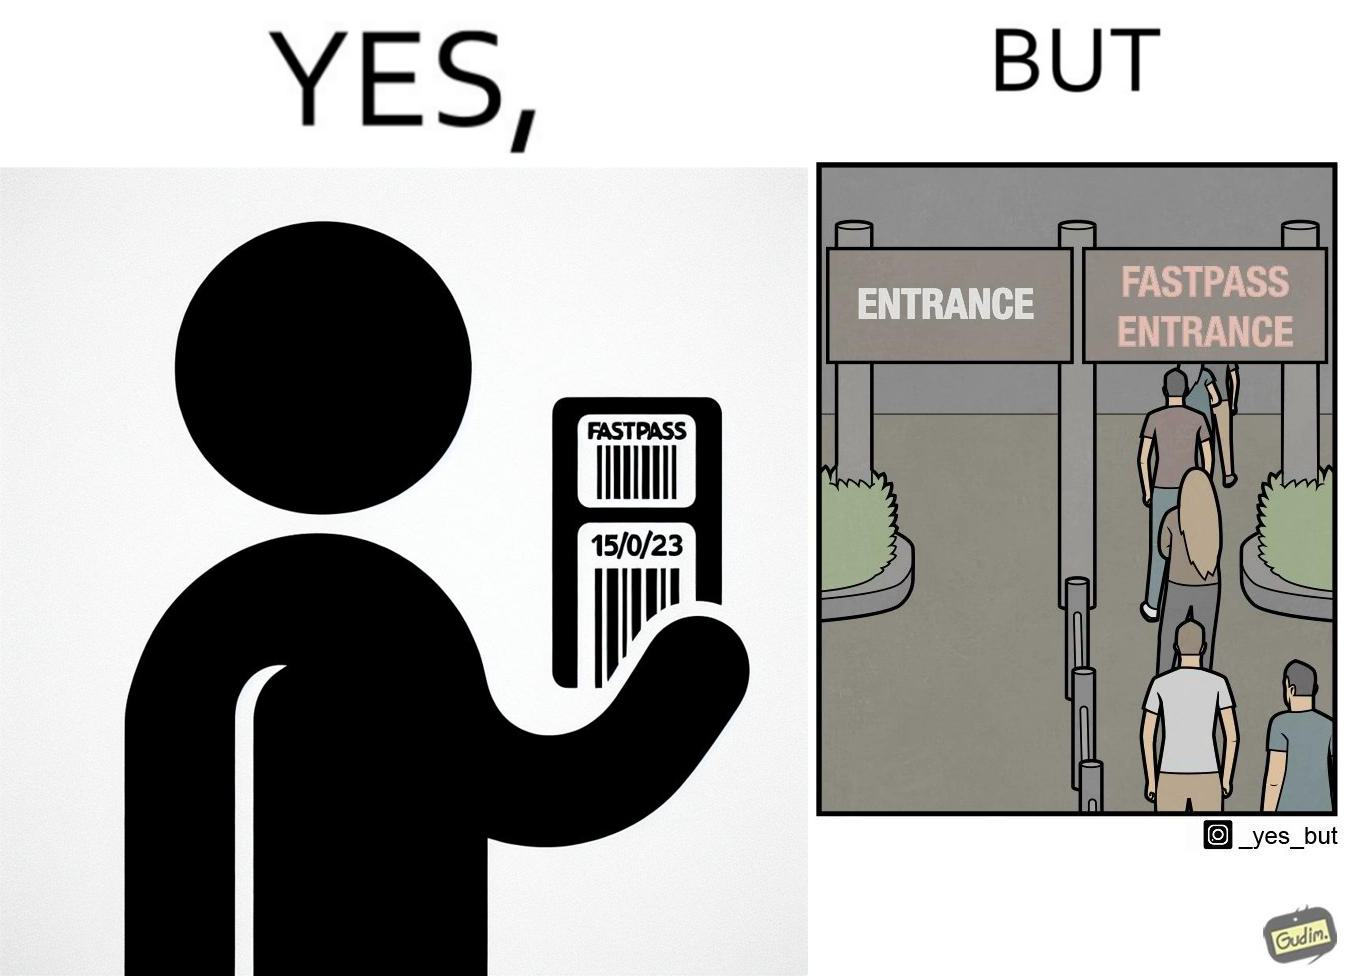What makes this image funny or satirical? The image is ironic, because fast pass entrance was meant for people to pass the gate fast but as more no. of people bought the pass due to which the queue has become longer and it becomes slow and time consuming 